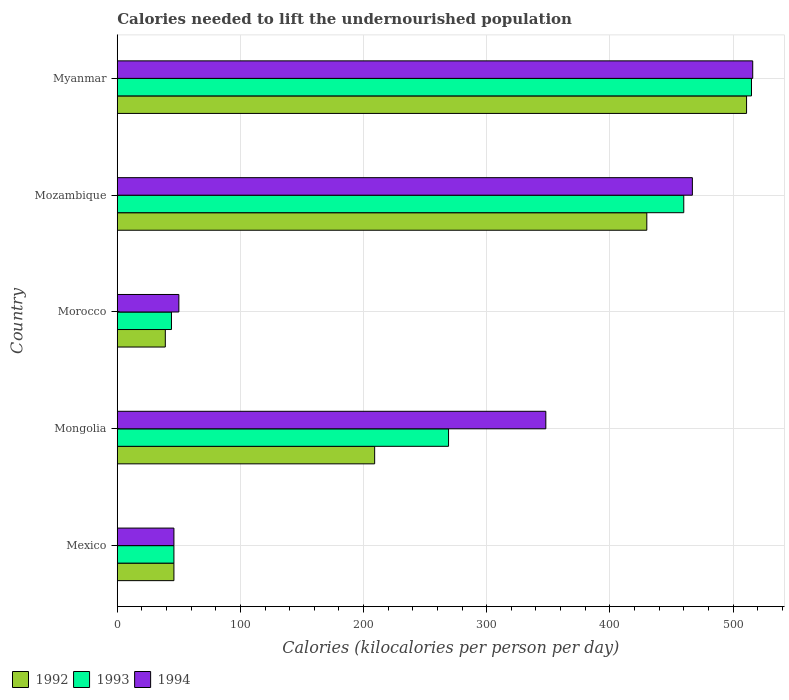How many different coloured bars are there?
Provide a succinct answer. 3. How many groups of bars are there?
Make the answer very short. 5. What is the label of the 1st group of bars from the top?
Keep it short and to the point. Myanmar. Across all countries, what is the maximum total calories needed to lift the undernourished population in 1992?
Your answer should be very brief. 511. In which country was the total calories needed to lift the undernourished population in 1993 maximum?
Keep it short and to the point. Myanmar. In which country was the total calories needed to lift the undernourished population in 1993 minimum?
Make the answer very short. Morocco. What is the total total calories needed to lift the undernourished population in 1993 in the graph?
Offer a very short reply. 1334. What is the difference between the total calories needed to lift the undernourished population in 1994 in Morocco and that in Myanmar?
Provide a succinct answer. -466. What is the average total calories needed to lift the undernourished population in 1992 per country?
Make the answer very short. 247. What is the difference between the total calories needed to lift the undernourished population in 1994 and total calories needed to lift the undernourished population in 1992 in Mongolia?
Give a very brief answer. 139. What is the ratio of the total calories needed to lift the undernourished population in 1993 in Mongolia to that in Mozambique?
Offer a very short reply. 0.58. What is the difference between the highest and the lowest total calories needed to lift the undernourished population in 1994?
Your answer should be compact. 470. How many bars are there?
Give a very brief answer. 15. Are all the bars in the graph horizontal?
Provide a short and direct response. Yes. Are the values on the major ticks of X-axis written in scientific E-notation?
Keep it short and to the point. No. Does the graph contain grids?
Provide a short and direct response. Yes. How many legend labels are there?
Make the answer very short. 3. How are the legend labels stacked?
Keep it short and to the point. Horizontal. What is the title of the graph?
Give a very brief answer. Calories needed to lift the undernourished population. What is the label or title of the X-axis?
Offer a very short reply. Calories (kilocalories per person per day). What is the label or title of the Y-axis?
Provide a short and direct response. Country. What is the Calories (kilocalories per person per day) in 1993 in Mexico?
Make the answer very short. 46. What is the Calories (kilocalories per person per day) in 1992 in Mongolia?
Provide a succinct answer. 209. What is the Calories (kilocalories per person per day) in 1993 in Mongolia?
Your response must be concise. 269. What is the Calories (kilocalories per person per day) of 1994 in Mongolia?
Provide a succinct answer. 348. What is the Calories (kilocalories per person per day) in 1992 in Morocco?
Make the answer very short. 39. What is the Calories (kilocalories per person per day) in 1994 in Morocco?
Keep it short and to the point. 50. What is the Calories (kilocalories per person per day) of 1992 in Mozambique?
Give a very brief answer. 430. What is the Calories (kilocalories per person per day) of 1993 in Mozambique?
Offer a terse response. 460. What is the Calories (kilocalories per person per day) of 1994 in Mozambique?
Make the answer very short. 467. What is the Calories (kilocalories per person per day) of 1992 in Myanmar?
Your answer should be very brief. 511. What is the Calories (kilocalories per person per day) of 1993 in Myanmar?
Provide a short and direct response. 515. What is the Calories (kilocalories per person per day) in 1994 in Myanmar?
Make the answer very short. 516. Across all countries, what is the maximum Calories (kilocalories per person per day) of 1992?
Make the answer very short. 511. Across all countries, what is the maximum Calories (kilocalories per person per day) in 1993?
Provide a succinct answer. 515. Across all countries, what is the maximum Calories (kilocalories per person per day) in 1994?
Your answer should be very brief. 516. Across all countries, what is the minimum Calories (kilocalories per person per day) in 1992?
Give a very brief answer. 39. Across all countries, what is the minimum Calories (kilocalories per person per day) in 1993?
Your answer should be compact. 44. What is the total Calories (kilocalories per person per day) of 1992 in the graph?
Your response must be concise. 1235. What is the total Calories (kilocalories per person per day) of 1993 in the graph?
Your answer should be very brief. 1334. What is the total Calories (kilocalories per person per day) in 1994 in the graph?
Keep it short and to the point. 1427. What is the difference between the Calories (kilocalories per person per day) of 1992 in Mexico and that in Mongolia?
Ensure brevity in your answer.  -163. What is the difference between the Calories (kilocalories per person per day) of 1993 in Mexico and that in Mongolia?
Keep it short and to the point. -223. What is the difference between the Calories (kilocalories per person per day) of 1994 in Mexico and that in Mongolia?
Offer a very short reply. -302. What is the difference between the Calories (kilocalories per person per day) of 1993 in Mexico and that in Morocco?
Your response must be concise. 2. What is the difference between the Calories (kilocalories per person per day) in 1992 in Mexico and that in Mozambique?
Provide a succinct answer. -384. What is the difference between the Calories (kilocalories per person per day) in 1993 in Mexico and that in Mozambique?
Offer a very short reply. -414. What is the difference between the Calories (kilocalories per person per day) of 1994 in Mexico and that in Mozambique?
Keep it short and to the point. -421. What is the difference between the Calories (kilocalories per person per day) of 1992 in Mexico and that in Myanmar?
Ensure brevity in your answer.  -465. What is the difference between the Calories (kilocalories per person per day) of 1993 in Mexico and that in Myanmar?
Your response must be concise. -469. What is the difference between the Calories (kilocalories per person per day) in 1994 in Mexico and that in Myanmar?
Give a very brief answer. -470. What is the difference between the Calories (kilocalories per person per day) of 1992 in Mongolia and that in Morocco?
Your answer should be very brief. 170. What is the difference between the Calories (kilocalories per person per day) in 1993 in Mongolia and that in Morocco?
Offer a terse response. 225. What is the difference between the Calories (kilocalories per person per day) of 1994 in Mongolia and that in Morocco?
Make the answer very short. 298. What is the difference between the Calories (kilocalories per person per day) of 1992 in Mongolia and that in Mozambique?
Keep it short and to the point. -221. What is the difference between the Calories (kilocalories per person per day) in 1993 in Mongolia and that in Mozambique?
Your answer should be very brief. -191. What is the difference between the Calories (kilocalories per person per day) of 1994 in Mongolia and that in Mozambique?
Offer a terse response. -119. What is the difference between the Calories (kilocalories per person per day) of 1992 in Mongolia and that in Myanmar?
Provide a short and direct response. -302. What is the difference between the Calories (kilocalories per person per day) in 1993 in Mongolia and that in Myanmar?
Your answer should be compact. -246. What is the difference between the Calories (kilocalories per person per day) in 1994 in Mongolia and that in Myanmar?
Give a very brief answer. -168. What is the difference between the Calories (kilocalories per person per day) in 1992 in Morocco and that in Mozambique?
Offer a terse response. -391. What is the difference between the Calories (kilocalories per person per day) in 1993 in Morocco and that in Mozambique?
Offer a terse response. -416. What is the difference between the Calories (kilocalories per person per day) of 1994 in Morocco and that in Mozambique?
Your response must be concise. -417. What is the difference between the Calories (kilocalories per person per day) of 1992 in Morocco and that in Myanmar?
Your answer should be compact. -472. What is the difference between the Calories (kilocalories per person per day) in 1993 in Morocco and that in Myanmar?
Make the answer very short. -471. What is the difference between the Calories (kilocalories per person per day) in 1994 in Morocco and that in Myanmar?
Provide a short and direct response. -466. What is the difference between the Calories (kilocalories per person per day) in 1992 in Mozambique and that in Myanmar?
Offer a terse response. -81. What is the difference between the Calories (kilocalories per person per day) in 1993 in Mozambique and that in Myanmar?
Offer a very short reply. -55. What is the difference between the Calories (kilocalories per person per day) of 1994 in Mozambique and that in Myanmar?
Your answer should be very brief. -49. What is the difference between the Calories (kilocalories per person per day) in 1992 in Mexico and the Calories (kilocalories per person per day) in 1993 in Mongolia?
Offer a terse response. -223. What is the difference between the Calories (kilocalories per person per day) of 1992 in Mexico and the Calories (kilocalories per person per day) of 1994 in Mongolia?
Your answer should be very brief. -302. What is the difference between the Calories (kilocalories per person per day) of 1993 in Mexico and the Calories (kilocalories per person per day) of 1994 in Mongolia?
Make the answer very short. -302. What is the difference between the Calories (kilocalories per person per day) of 1992 in Mexico and the Calories (kilocalories per person per day) of 1994 in Morocco?
Your response must be concise. -4. What is the difference between the Calories (kilocalories per person per day) in 1992 in Mexico and the Calories (kilocalories per person per day) in 1993 in Mozambique?
Offer a terse response. -414. What is the difference between the Calories (kilocalories per person per day) of 1992 in Mexico and the Calories (kilocalories per person per day) of 1994 in Mozambique?
Ensure brevity in your answer.  -421. What is the difference between the Calories (kilocalories per person per day) of 1993 in Mexico and the Calories (kilocalories per person per day) of 1994 in Mozambique?
Make the answer very short. -421. What is the difference between the Calories (kilocalories per person per day) in 1992 in Mexico and the Calories (kilocalories per person per day) in 1993 in Myanmar?
Offer a terse response. -469. What is the difference between the Calories (kilocalories per person per day) in 1992 in Mexico and the Calories (kilocalories per person per day) in 1994 in Myanmar?
Your response must be concise. -470. What is the difference between the Calories (kilocalories per person per day) of 1993 in Mexico and the Calories (kilocalories per person per day) of 1994 in Myanmar?
Offer a very short reply. -470. What is the difference between the Calories (kilocalories per person per day) in 1992 in Mongolia and the Calories (kilocalories per person per day) in 1993 in Morocco?
Your answer should be compact. 165. What is the difference between the Calories (kilocalories per person per day) of 1992 in Mongolia and the Calories (kilocalories per person per day) of 1994 in Morocco?
Your answer should be very brief. 159. What is the difference between the Calories (kilocalories per person per day) in 1993 in Mongolia and the Calories (kilocalories per person per day) in 1994 in Morocco?
Keep it short and to the point. 219. What is the difference between the Calories (kilocalories per person per day) in 1992 in Mongolia and the Calories (kilocalories per person per day) in 1993 in Mozambique?
Offer a terse response. -251. What is the difference between the Calories (kilocalories per person per day) in 1992 in Mongolia and the Calories (kilocalories per person per day) in 1994 in Mozambique?
Your answer should be very brief. -258. What is the difference between the Calories (kilocalories per person per day) of 1993 in Mongolia and the Calories (kilocalories per person per day) of 1994 in Mozambique?
Make the answer very short. -198. What is the difference between the Calories (kilocalories per person per day) in 1992 in Mongolia and the Calories (kilocalories per person per day) in 1993 in Myanmar?
Keep it short and to the point. -306. What is the difference between the Calories (kilocalories per person per day) in 1992 in Mongolia and the Calories (kilocalories per person per day) in 1994 in Myanmar?
Offer a very short reply. -307. What is the difference between the Calories (kilocalories per person per day) in 1993 in Mongolia and the Calories (kilocalories per person per day) in 1994 in Myanmar?
Offer a terse response. -247. What is the difference between the Calories (kilocalories per person per day) in 1992 in Morocco and the Calories (kilocalories per person per day) in 1993 in Mozambique?
Give a very brief answer. -421. What is the difference between the Calories (kilocalories per person per day) in 1992 in Morocco and the Calories (kilocalories per person per day) in 1994 in Mozambique?
Make the answer very short. -428. What is the difference between the Calories (kilocalories per person per day) of 1993 in Morocco and the Calories (kilocalories per person per day) of 1994 in Mozambique?
Make the answer very short. -423. What is the difference between the Calories (kilocalories per person per day) in 1992 in Morocco and the Calories (kilocalories per person per day) in 1993 in Myanmar?
Your answer should be compact. -476. What is the difference between the Calories (kilocalories per person per day) of 1992 in Morocco and the Calories (kilocalories per person per day) of 1994 in Myanmar?
Keep it short and to the point. -477. What is the difference between the Calories (kilocalories per person per day) of 1993 in Morocco and the Calories (kilocalories per person per day) of 1994 in Myanmar?
Make the answer very short. -472. What is the difference between the Calories (kilocalories per person per day) in 1992 in Mozambique and the Calories (kilocalories per person per day) in 1993 in Myanmar?
Offer a terse response. -85. What is the difference between the Calories (kilocalories per person per day) in 1992 in Mozambique and the Calories (kilocalories per person per day) in 1994 in Myanmar?
Your answer should be compact. -86. What is the difference between the Calories (kilocalories per person per day) of 1993 in Mozambique and the Calories (kilocalories per person per day) of 1994 in Myanmar?
Provide a short and direct response. -56. What is the average Calories (kilocalories per person per day) of 1992 per country?
Your answer should be very brief. 247. What is the average Calories (kilocalories per person per day) of 1993 per country?
Offer a very short reply. 266.8. What is the average Calories (kilocalories per person per day) in 1994 per country?
Offer a terse response. 285.4. What is the difference between the Calories (kilocalories per person per day) of 1992 and Calories (kilocalories per person per day) of 1994 in Mexico?
Keep it short and to the point. 0. What is the difference between the Calories (kilocalories per person per day) of 1993 and Calories (kilocalories per person per day) of 1994 in Mexico?
Provide a succinct answer. 0. What is the difference between the Calories (kilocalories per person per day) in 1992 and Calories (kilocalories per person per day) in 1993 in Mongolia?
Make the answer very short. -60. What is the difference between the Calories (kilocalories per person per day) in 1992 and Calories (kilocalories per person per day) in 1994 in Mongolia?
Keep it short and to the point. -139. What is the difference between the Calories (kilocalories per person per day) in 1993 and Calories (kilocalories per person per day) in 1994 in Mongolia?
Keep it short and to the point. -79. What is the difference between the Calories (kilocalories per person per day) of 1993 and Calories (kilocalories per person per day) of 1994 in Morocco?
Offer a very short reply. -6. What is the difference between the Calories (kilocalories per person per day) in 1992 and Calories (kilocalories per person per day) in 1993 in Mozambique?
Give a very brief answer. -30. What is the difference between the Calories (kilocalories per person per day) in 1992 and Calories (kilocalories per person per day) in 1994 in Mozambique?
Provide a succinct answer. -37. What is the difference between the Calories (kilocalories per person per day) of 1993 and Calories (kilocalories per person per day) of 1994 in Mozambique?
Your answer should be very brief. -7. What is the difference between the Calories (kilocalories per person per day) in 1992 and Calories (kilocalories per person per day) in 1993 in Myanmar?
Provide a succinct answer. -4. What is the ratio of the Calories (kilocalories per person per day) of 1992 in Mexico to that in Mongolia?
Give a very brief answer. 0.22. What is the ratio of the Calories (kilocalories per person per day) in 1993 in Mexico to that in Mongolia?
Your answer should be compact. 0.17. What is the ratio of the Calories (kilocalories per person per day) of 1994 in Mexico to that in Mongolia?
Offer a terse response. 0.13. What is the ratio of the Calories (kilocalories per person per day) in 1992 in Mexico to that in Morocco?
Provide a succinct answer. 1.18. What is the ratio of the Calories (kilocalories per person per day) of 1993 in Mexico to that in Morocco?
Give a very brief answer. 1.05. What is the ratio of the Calories (kilocalories per person per day) in 1992 in Mexico to that in Mozambique?
Provide a succinct answer. 0.11. What is the ratio of the Calories (kilocalories per person per day) in 1994 in Mexico to that in Mozambique?
Your answer should be very brief. 0.1. What is the ratio of the Calories (kilocalories per person per day) of 1992 in Mexico to that in Myanmar?
Ensure brevity in your answer.  0.09. What is the ratio of the Calories (kilocalories per person per day) of 1993 in Mexico to that in Myanmar?
Offer a very short reply. 0.09. What is the ratio of the Calories (kilocalories per person per day) of 1994 in Mexico to that in Myanmar?
Your answer should be compact. 0.09. What is the ratio of the Calories (kilocalories per person per day) of 1992 in Mongolia to that in Morocco?
Give a very brief answer. 5.36. What is the ratio of the Calories (kilocalories per person per day) in 1993 in Mongolia to that in Morocco?
Your response must be concise. 6.11. What is the ratio of the Calories (kilocalories per person per day) in 1994 in Mongolia to that in Morocco?
Offer a very short reply. 6.96. What is the ratio of the Calories (kilocalories per person per day) in 1992 in Mongolia to that in Mozambique?
Make the answer very short. 0.49. What is the ratio of the Calories (kilocalories per person per day) of 1993 in Mongolia to that in Mozambique?
Keep it short and to the point. 0.58. What is the ratio of the Calories (kilocalories per person per day) of 1994 in Mongolia to that in Mozambique?
Offer a very short reply. 0.75. What is the ratio of the Calories (kilocalories per person per day) in 1992 in Mongolia to that in Myanmar?
Ensure brevity in your answer.  0.41. What is the ratio of the Calories (kilocalories per person per day) of 1993 in Mongolia to that in Myanmar?
Provide a succinct answer. 0.52. What is the ratio of the Calories (kilocalories per person per day) of 1994 in Mongolia to that in Myanmar?
Offer a terse response. 0.67. What is the ratio of the Calories (kilocalories per person per day) in 1992 in Morocco to that in Mozambique?
Ensure brevity in your answer.  0.09. What is the ratio of the Calories (kilocalories per person per day) of 1993 in Morocco to that in Mozambique?
Your answer should be compact. 0.1. What is the ratio of the Calories (kilocalories per person per day) of 1994 in Morocco to that in Mozambique?
Provide a succinct answer. 0.11. What is the ratio of the Calories (kilocalories per person per day) in 1992 in Morocco to that in Myanmar?
Ensure brevity in your answer.  0.08. What is the ratio of the Calories (kilocalories per person per day) in 1993 in Morocco to that in Myanmar?
Give a very brief answer. 0.09. What is the ratio of the Calories (kilocalories per person per day) of 1994 in Morocco to that in Myanmar?
Ensure brevity in your answer.  0.1. What is the ratio of the Calories (kilocalories per person per day) of 1992 in Mozambique to that in Myanmar?
Ensure brevity in your answer.  0.84. What is the ratio of the Calories (kilocalories per person per day) of 1993 in Mozambique to that in Myanmar?
Ensure brevity in your answer.  0.89. What is the ratio of the Calories (kilocalories per person per day) in 1994 in Mozambique to that in Myanmar?
Make the answer very short. 0.91. What is the difference between the highest and the second highest Calories (kilocalories per person per day) in 1992?
Your response must be concise. 81. What is the difference between the highest and the lowest Calories (kilocalories per person per day) of 1992?
Offer a terse response. 472. What is the difference between the highest and the lowest Calories (kilocalories per person per day) in 1993?
Your answer should be very brief. 471. What is the difference between the highest and the lowest Calories (kilocalories per person per day) in 1994?
Offer a very short reply. 470. 